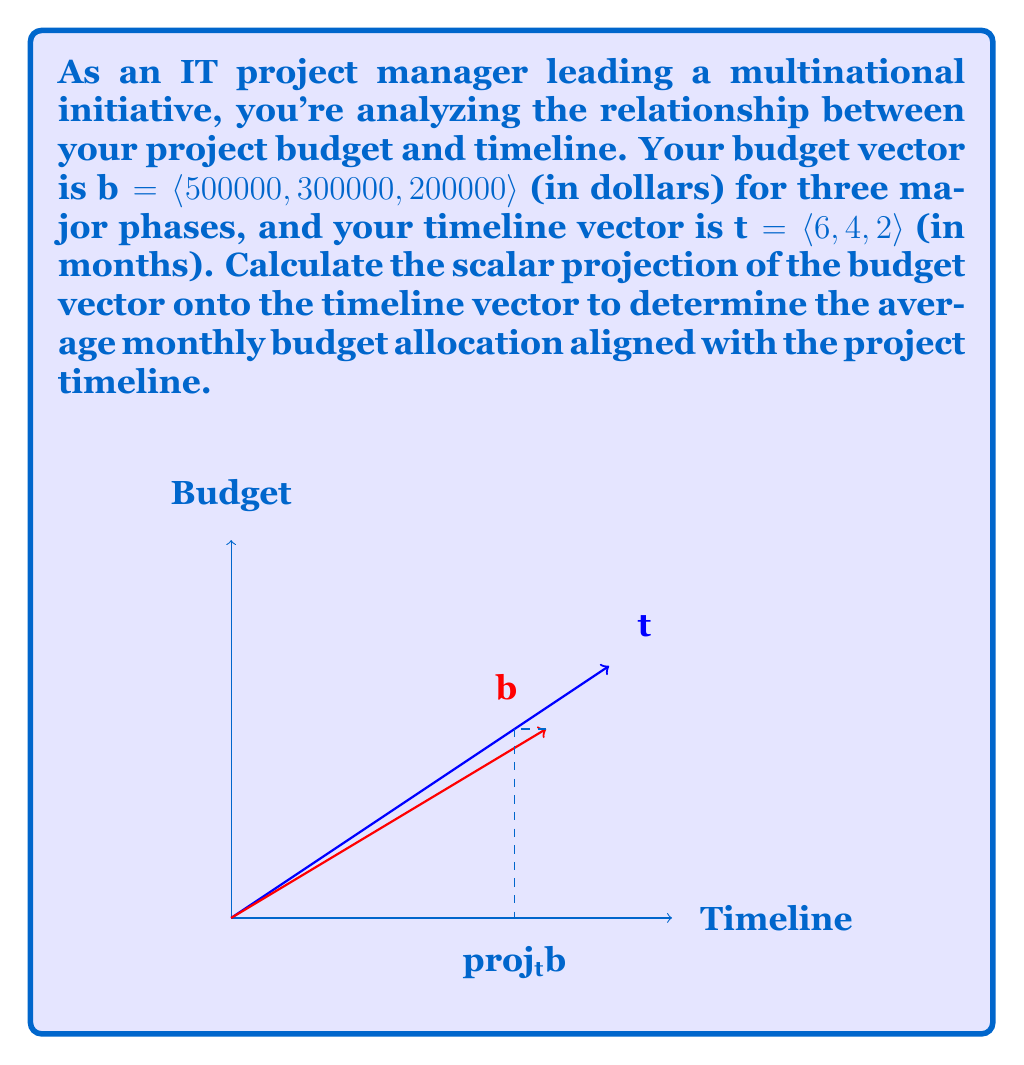Provide a solution to this math problem. To solve this problem, we'll use the formula for scalar projection:

$$\text{proj}_\mathbf{t}\mathbf{b} = \frac{\mathbf{b} \cdot \mathbf{t}}{|\mathbf{t}|^2} |\mathbf{t}|$$

Step 1: Calculate the dot product of $\mathbf{b}$ and $\mathbf{t}$
$$\mathbf{b} \cdot \mathbf{t} = (500000 \times 6) + (300000 \times 4) + (200000 \times 2) = 4,400,000$$

Step 2: Calculate the magnitude of $\mathbf{t}$ squared
$$|\mathbf{t}|^2 = 6^2 + 4^2 + 2^2 = 56$$

Step 3: Calculate the magnitude of $\mathbf{t}$
$$|\mathbf{t}| = \sqrt{56} \approx 7.4833$$

Step 4: Apply the scalar projection formula
$$\text{proj}_\mathbf{t}\mathbf{b} = \frac{4,400,000}{56} \times 7.4833 \approx 586,545.45$$

This result represents the average monthly budget allocation aligned with the project timeline.
Answer: $586,545.45 